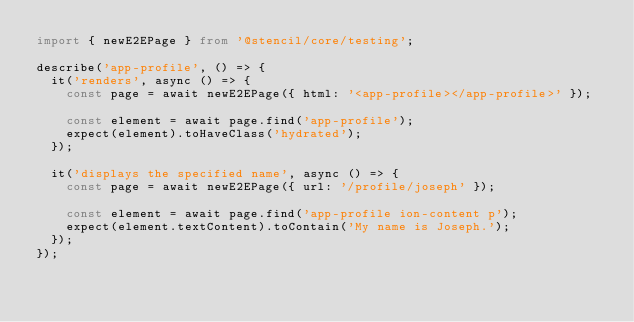Convert code to text. <code><loc_0><loc_0><loc_500><loc_500><_TypeScript_>import { newE2EPage } from '@stencil/core/testing';

describe('app-profile', () => {
  it('renders', async () => {
    const page = await newE2EPage({ html: '<app-profile></app-profile>' });

    const element = await page.find('app-profile');
    expect(element).toHaveClass('hydrated');
  });

  it('displays the specified name', async () => {
    const page = await newE2EPage({ url: '/profile/joseph' });

    const element = await page.find('app-profile ion-content p');
    expect(element.textContent).toContain('My name is Joseph.');
  });
});
</code> 